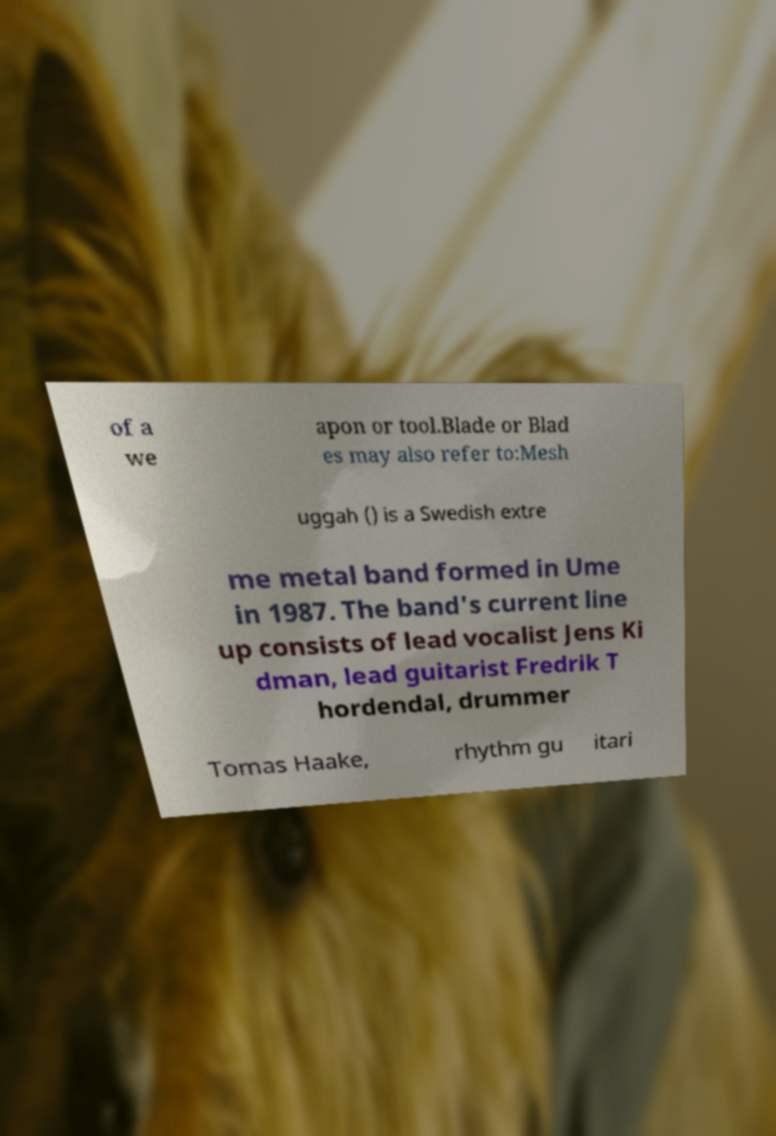For documentation purposes, I need the text within this image transcribed. Could you provide that? of a we apon or tool.Blade or Blad es may also refer to:Mesh uggah () is a Swedish extre me metal band formed in Ume in 1987. The band's current line up consists of lead vocalist Jens Ki dman, lead guitarist Fredrik T hordendal, drummer Tomas Haake, rhythm gu itari 